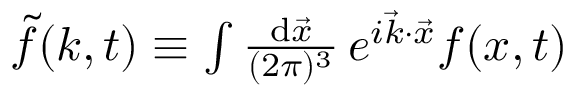<formula> <loc_0><loc_0><loc_500><loc_500>\begin{array} { r } { \widetilde { f } ( k , t ) \equiv \int \frac { d \vec { x } } { ( 2 \pi ) ^ { 3 } } \, e ^ { i \vec { k } \cdot \vec { x } } f ( x , t ) } \end{array}</formula> 